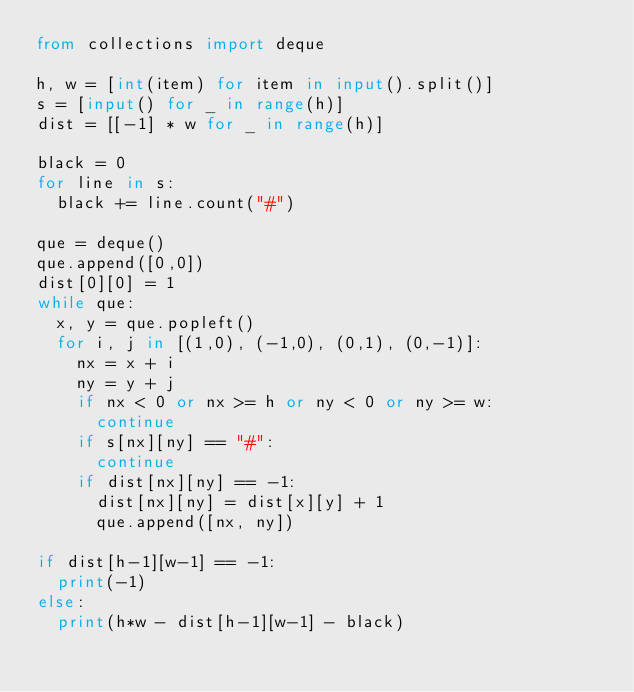Convert code to text. <code><loc_0><loc_0><loc_500><loc_500><_Python_>from collections import deque

h, w = [int(item) for item in input().split()]
s = [input() for _ in range(h)]
dist = [[-1] * w for _ in range(h)]

black = 0
for line in s:
  black += line.count("#")

que = deque()
que.append([0,0])
dist[0][0] = 1
while que:
  x, y = que.popleft()
  for i, j in [(1,0), (-1,0), (0,1), (0,-1)]:
    nx = x + i
    ny = y + j
    if nx < 0 or nx >= h or ny < 0 or ny >= w:
      continue
    if s[nx][ny] == "#":
      continue
    if dist[nx][ny] == -1:
      dist[nx][ny] = dist[x][y] + 1
      que.append([nx, ny])

if dist[h-1][w-1] == -1:
  print(-1)
else:
  print(h*w - dist[h-1][w-1] - black)</code> 